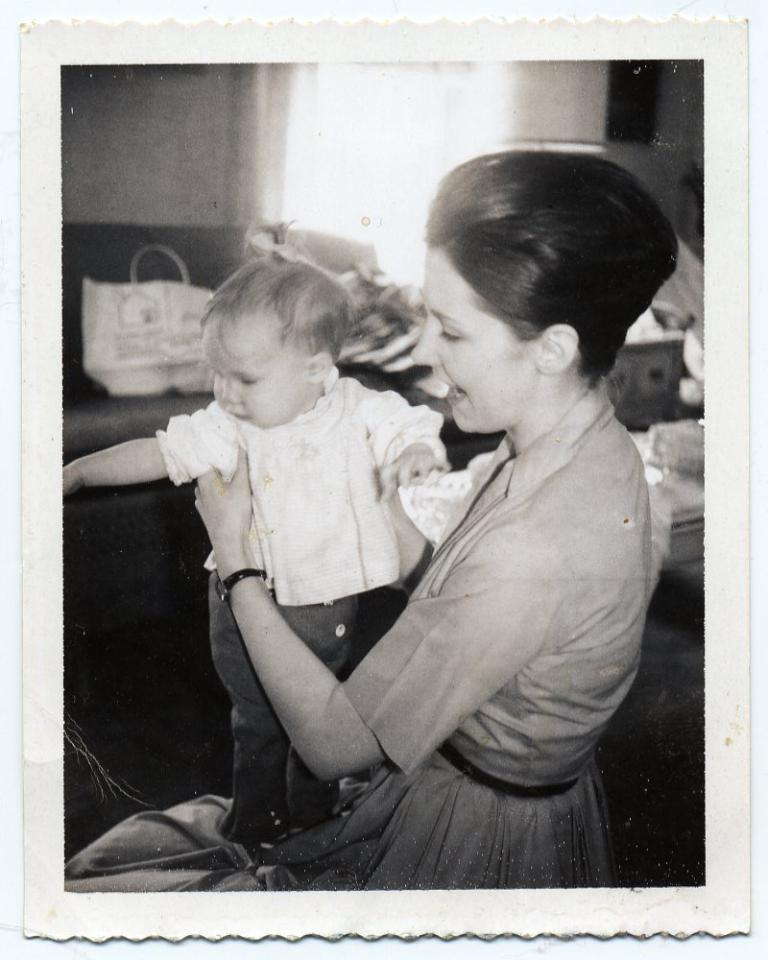What is the main subject of the image? There is a photo in the image. What can be seen in the photo? The photo contains a woman holding a baby. What else is visible in the image besides the photo? There is a bag and other objects in the image. What type of bean is being exchanged between the woman and the baby in the image? There is no bean present in the image, nor is there any indication of an exchange between the woman and the baby. 